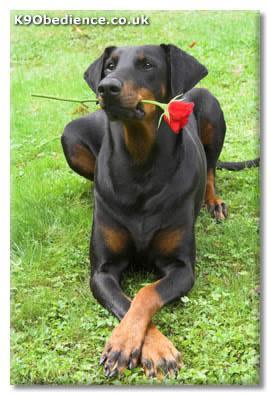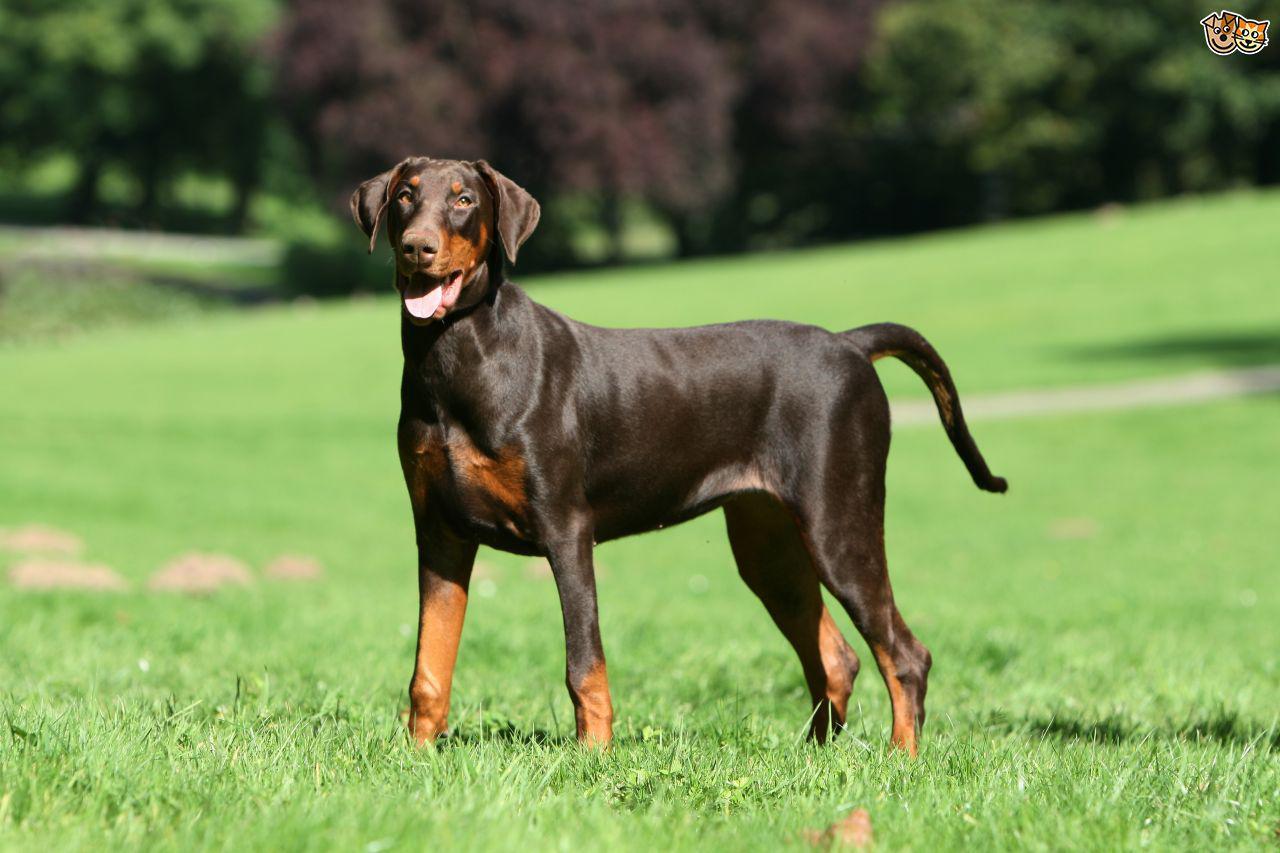The first image is the image on the left, the second image is the image on the right. Assess this claim about the two images: "The dog in the image on the left has its mouth closed.". Correct or not? Answer yes or no. Yes. The first image is the image on the left, the second image is the image on the right. Considering the images on both sides, is "There are dogs standing in each image" valid? Answer yes or no. No. 